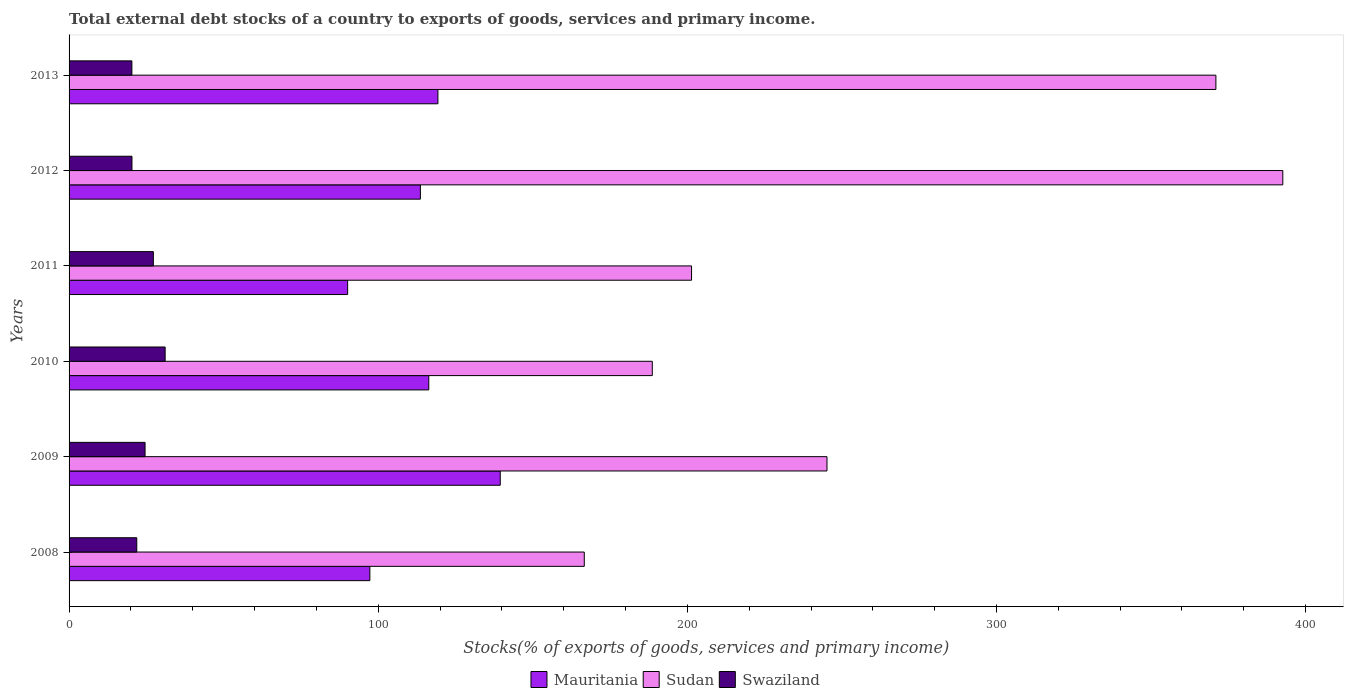How many groups of bars are there?
Keep it short and to the point. 6. Are the number of bars on each tick of the Y-axis equal?
Your response must be concise. Yes. How many bars are there on the 1st tick from the top?
Keep it short and to the point. 3. How many bars are there on the 6th tick from the bottom?
Offer a terse response. 3. What is the total debt stocks in Mauritania in 2010?
Your answer should be very brief. 116.36. Across all years, what is the maximum total debt stocks in Mauritania?
Give a very brief answer. 139.47. Across all years, what is the minimum total debt stocks in Sudan?
Make the answer very short. 166.66. In which year was the total debt stocks in Swaziland minimum?
Offer a terse response. 2013. What is the total total debt stocks in Swaziland in the graph?
Offer a terse response. 145.49. What is the difference between the total debt stocks in Mauritania in 2009 and that in 2011?
Ensure brevity in your answer.  49.37. What is the difference between the total debt stocks in Sudan in 2008 and the total debt stocks in Mauritania in 2012?
Make the answer very short. 53.01. What is the average total debt stocks in Swaziland per year?
Keep it short and to the point. 24.25. In the year 2011, what is the difference between the total debt stocks in Sudan and total debt stocks in Swaziland?
Your answer should be very brief. 174.09. What is the ratio of the total debt stocks in Mauritania in 2012 to that in 2013?
Provide a short and direct response. 0.95. Is the difference between the total debt stocks in Sudan in 2009 and 2011 greater than the difference between the total debt stocks in Swaziland in 2009 and 2011?
Your answer should be very brief. Yes. What is the difference between the highest and the second highest total debt stocks in Swaziland?
Your response must be concise. 3.81. What is the difference between the highest and the lowest total debt stocks in Mauritania?
Provide a short and direct response. 49.37. Is the sum of the total debt stocks in Swaziland in 2010 and 2012 greater than the maximum total debt stocks in Mauritania across all years?
Keep it short and to the point. No. What does the 2nd bar from the top in 2008 represents?
Make the answer very short. Sudan. What does the 3rd bar from the bottom in 2010 represents?
Your answer should be very brief. Swaziland. How many bars are there?
Provide a short and direct response. 18. How many years are there in the graph?
Your answer should be compact. 6. What is the difference between two consecutive major ticks on the X-axis?
Offer a terse response. 100. Does the graph contain any zero values?
Keep it short and to the point. No. How are the legend labels stacked?
Keep it short and to the point. Horizontal. What is the title of the graph?
Your answer should be very brief. Total external debt stocks of a country to exports of goods, services and primary income. Does "Middle East & North Africa (developing only)" appear as one of the legend labels in the graph?
Offer a terse response. No. What is the label or title of the X-axis?
Your answer should be very brief. Stocks(% of exports of goods, services and primary income). What is the label or title of the Y-axis?
Provide a succinct answer. Years. What is the Stocks(% of exports of goods, services and primary income) in Mauritania in 2008?
Offer a terse response. 97.3. What is the Stocks(% of exports of goods, services and primary income) in Sudan in 2008?
Give a very brief answer. 166.66. What is the Stocks(% of exports of goods, services and primary income) of Swaziland in 2008?
Offer a terse response. 21.91. What is the Stocks(% of exports of goods, services and primary income) in Mauritania in 2009?
Provide a succinct answer. 139.47. What is the Stocks(% of exports of goods, services and primary income) in Sudan in 2009?
Ensure brevity in your answer.  245.16. What is the Stocks(% of exports of goods, services and primary income) in Swaziland in 2009?
Your response must be concise. 24.58. What is the Stocks(% of exports of goods, services and primary income) in Mauritania in 2010?
Provide a short and direct response. 116.36. What is the Stocks(% of exports of goods, services and primary income) of Sudan in 2010?
Your answer should be compact. 188.66. What is the Stocks(% of exports of goods, services and primary income) of Swaziland in 2010?
Provide a short and direct response. 31.08. What is the Stocks(% of exports of goods, services and primary income) in Mauritania in 2011?
Your response must be concise. 90.11. What is the Stocks(% of exports of goods, services and primary income) in Sudan in 2011?
Ensure brevity in your answer.  201.36. What is the Stocks(% of exports of goods, services and primary income) in Swaziland in 2011?
Keep it short and to the point. 27.26. What is the Stocks(% of exports of goods, services and primary income) in Mauritania in 2012?
Give a very brief answer. 113.64. What is the Stocks(% of exports of goods, services and primary income) in Sudan in 2012?
Provide a succinct answer. 392.61. What is the Stocks(% of exports of goods, services and primary income) of Swaziland in 2012?
Keep it short and to the point. 20.34. What is the Stocks(% of exports of goods, services and primary income) of Mauritania in 2013?
Your answer should be compact. 119.31. What is the Stocks(% of exports of goods, services and primary income) of Sudan in 2013?
Offer a very short reply. 370.97. What is the Stocks(% of exports of goods, services and primary income) in Swaziland in 2013?
Offer a terse response. 20.32. Across all years, what is the maximum Stocks(% of exports of goods, services and primary income) in Mauritania?
Your answer should be compact. 139.47. Across all years, what is the maximum Stocks(% of exports of goods, services and primary income) of Sudan?
Offer a very short reply. 392.61. Across all years, what is the maximum Stocks(% of exports of goods, services and primary income) in Swaziland?
Your response must be concise. 31.08. Across all years, what is the minimum Stocks(% of exports of goods, services and primary income) of Mauritania?
Your response must be concise. 90.11. Across all years, what is the minimum Stocks(% of exports of goods, services and primary income) of Sudan?
Offer a very short reply. 166.66. Across all years, what is the minimum Stocks(% of exports of goods, services and primary income) in Swaziland?
Provide a succinct answer. 20.32. What is the total Stocks(% of exports of goods, services and primary income) in Mauritania in the graph?
Your answer should be compact. 676.2. What is the total Stocks(% of exports of goods, services and primary income) in Sudan in the graph?
Your answer should be compact. 1565.42. What is the total Stocks(% of exports of goods, services and primary income) of Swaziland in the graph?
Your answer should be compact. 145.49. What is the difference between the Stocks(% of exports of goods, services and primary income) in Mauritania in 2008 and that in 2009?
Ensure brevity in your answer.  -42.18. What is the difference between the Stocks(% of exports of goods, services and primary income) in Sudan in 2008 and that in 2009?
Keep it short and to the point. -78.51. What is the difference between the Stocks(% of exports of goods, services and primary income) of Swaziland in 2008 and that in 2009?
Provide a short and direct response. -2.68. What is the difference between the Stocks(% of exports of goods, services and primary income) of Mauritania in 2008 and that in 2010?
Offer a terse response. -19.06. What is the difference between the Stocks(% of exports of goods, services and primary income) in Sudan in 2008 and that in 2010?
Give a very brief answer. -22. What is the difference between the Stocks(% of exports of goods, services and primary income) of Swaziland in 2008 and that in 2010?
Ensure brevity in your answer.  -9.17. What is the difference between the Stocks(% of exports of goods, services and primary income) of Mauritania in 2008 and that in 2011?
Your response must be concise. 7.19. What is the difference between the Stocks(% of exports of goods, services and primary income) of Sudan in 2008 and that in 2011?
Keep it short and to the point. -34.7. What is the difference between the Stocks(% of exports of goods, services and primary income) in Swaziland in 2008 and that in 2011?
Provide a short and direct response. -5.36. What is the difference between the Stocks(% of exports of goods, services and primary income) in Mauritania in 2008 and that in 2012?
Your answer should be compact. -16.35. What is the difference between the Stocks(% of exports of goods, services and primary income) of Sudan in 2008 and that in 2012?
Give a very brief answer. -225.96. What is the difference between the Stocks(% of exports of goods, services and primary income) in Swaziland in 2008 and that in 2012?
Offer a very short reply. 1.56. What is the difference between the Stocks(% of exports of goods, services and primary income) of Mauritania in 2008 and that in 2013?
Provide a short and direct response. -22.01. What is the difference between the Stocks(% of exports of goods, services and primary income) in Sudan in 2008 and that in 2013?
Offer a terse response. -204.31. What is the difference between the Stocks(% of exports of goods, services and primary income) of Swaziland in 2008 and that in 2013?
Make the answer very short. 1.58. What is the difference between the Stocks(% of exports of goods, services and primary income) of Mauritania in 2009 and that in 2010?
Make the answer very short. 23.12. What is the difference between the Stocks(% of exports of goods, services and primary income) in Sudan in 2009 and that in 2010?
Keep it short and to the point. 56.51. What is the difference between the Stocks(% of exports of goods, services and primary income) in Swaziland in 2009 and that in 2010?
Offer a very short reply. -6.49. What is the difference between the Stocks(% of exports of goods, services and primary income) of Mauritania in 2009 and that in 2011?
Offer a terse response. 49.37. What is the difference between the Stocks(% of exports of goods, services and primary income) in Sudan in 2009 and that in 2011?
Ensure brevity in your answer.  43.81. What is the difference between the Stocks(% of exports of goods, services and primary income) in Swaziland in 2009 and that in 2011?
Your response must be concise. -2.68. What is the difference between the Stocks(% of exports of goods, services and primary income) in Mauritania in 2009 and that in 2012?
Provide a short and direct response. 25.83. What is the difference between the Stocks(% of exports of goods, services and primary income) of Sudan in 2009 and that in 2012?
Your answer should be compact. -147.45. What is the difference between the Stocks(% of exports of goods, services and primary income) of Swaziland in 2009 and that in 2012?
Make the answer very short. 4.24. What is the difference between the Stocks(% of exports of goods, services and primary income) in Mauritania in 2009 and that in 2013?
Ensure brevity in your answer.  20.16. What is the difference between the Stocks(% of exports of goods, services and primary income) in Sudan in 2009 and that in 2013?
Your response must be concise. -125.81. What is the difference between the Stocks(% of exports of goods, services and primary income) of Swaziland in 2009 and that in 2013?
Give a very brief answer. 4.26. What is the difference between the Stocks(% of exports of goods, services and primary income) in Mauritania in 2010 and that in 2011?
Give a very brief answer. 26.25. What is the difference between the Stocks(% of exports of goods, services and primary income) of Sudan in 2010 and that in 2011?
Ensure brevity in your answer.  -12.7. What is the difference between the Stocks(% of exports of goods, services and primary income) of Swaziland in 2010 and that in 2011?
Offer a very short reply. 3.81. What is the difference between the Stocks(% of exports of goods, services and primary income) of Mauritania in 2010 and that in 2012?
Your response must be concise. 2.71. What is the difference between the Stocks(% of exports of goods, services and primary income) in Sudan in 2010 and that in 2012?
Give a very brief answer. -203.96. What is the difference between the Stocks(% of exports of goods, services and primary income) in Swaziland in 2010 and that in 2012?
Your answer should be compact. 10.73. What is the difference between the Stocks(% of exports of goods, services and primary income) in Mauritania in 2010 and that in 2013?
Your response must be concise. -2.96. What is the difference between the Stocks(% of exports of goods, services and primary income) of Sudan in 2010 and that in 2013?
Give a very brief answer. -182.31. What is the difference between the Stocks(% of exports of goods, services and primary income) in Swaziland in 2010 and that in 2013?
Offer a terse response. 10.76. What is the difference between the Stocks(% of exports of goods, services and primary income) in Mauritania in 2011 and that in 2012?
Make the answer very short. -23.53. What is the difference between the Stocks(% of exports of goods, services and primary income) of Sudan in 2011 and that in 2012?
Provide a short and direct response. -191.26. What is the difference between the Stocks(% of exports of goods, services and primary income) in Swaziland in 2011 and that in 2012?
Give a very brief answer. 6.92. What is the difference between the Stocks(% of exports of goods, services and primary income) of Mauritania in 2011 and that in 2013?
Provide a succinct answer. -29.2. What is the difference between the Stocks(% of exports of goods, services and primary income) of Sudan in 2011 and that in 2013?
Ensure brevity in your answer.  -169.61. What is the difference between the Stocks(% of exports of goods, services and primary income) in Swaziland in 2011 and that in 2013?
Your answer should be compact. 6.94. What is the difference between the Stocks(% of exports of goods, services and primary income) in Mauritania in 2012 and that in 2013?
Keep it short and to the point. -5.67. What is the difference between the Stocks(% of exports of goods, services and primary income) in Sudan in 2012 and that in 2013?
Make the answer very short. 21.64. What is the difference between the Stocks(% of exports of goods, services and primary income) in Swaziland in 2012 and that in 2013?
Your response must be concise. 0.02. What is the difference between the Stocks(% of exports of goods, services and primary income) in Mauritania in 2008 and the Stocks(% of exports of goods, services and primary income) in Sudan in 2009?
Provide a short and direct response. -147.87. What is the difference between the Stocks(% of exports of goods, services and primary income) of Mauritania in 2008 and the Stocks(% of exports of goods, services and primary income) of Swaziland in 2009?
Make the answer very short. 72.72. What is the difference between the Stocks(% of exports of goods, services and primary income) of Sudan in 2008 and the Stocks(% of exports of goods, services and primary income) of Swaziland in 2009?
Your answer should be very brief. 142.07. What is the difference between the Stocks(% of exports of goods, services and primary income) in Mauritania in 2008 and the Stocks(% of exports of goods, services and primary income) in Sudan in 2010?
Give a very brief answer. -91.36. What is the difference between the Stocks(% of exports of goods, services and primary income) of Mauritania in 2008 and the Stocks(% of exports of goods, services and primary income) of Swaziland in 2010?
Provide a succinct answer. 66.22. What is the difference between the Stocks(% of exports of goods, services and primary income) of Sudan in 2008 and the Stocks(% of exports of goods, services and primary income) of Swaziland in 2010?
Your answer should be compact. 135.58. What is the difference between the Stocks(% of exports of goods, services and primary income) in Mauritania in 2008 and the Stocks(% of exports of goods, services and primary income) in Sudan in 2011?
Your response must be concise. -104.06. What is the difference between the Stocks(% of exports of goods, services and primary income) in Mauritania in 2008 and the Stocks(% of exports of goods, services and primary income) in Swaziland in 2011?
Offer a very short reply. 70.03. What is the difference between the Stocks(% of exports of goods, services and primary income) of Sudan in 2008 and the Stocks(% of exports of goods, services and primary income) of Swaziland in 2011?
Provide a short and direct response. 139.39. What is the difference between the Stocks(% of exports of goods, services and primary income) in Mauritania in 2008 and the Stocks(% of exports of goods, services and primary income) in Sudan in 2012?
Provide a succinct answer. -295.31. What is the difference between the Stocks(% of exports of goods, services and primary income) in Mauritania in 2008 and the Stocks(% of exports of goods, services and primary income) in Swaziland in 2012?
Offer a terse response. 76.96. What is the difference between the Stocks(% of exports of goods, services and primary income) in Sudan in 2008 and the Stocks(% of exports of goods, services and primary income) in Swaziland in 2012?
Ensure brevity in your answer.  146.31. What is the difference between the Stocks(% of exports of goods, services and primary income) in Mauritania in 2008 and the Stocks(% of exports of goods, services and primary income) in Sudan in 2013?
Provide a succinct answer. -273.67. What is the difference between the Stocks(% of exports of goods, services and primary income) in Mauritania in 2008 and the Stocks(% of exports of goods, services and primary income) in Swaziland in 2013?
Give a very brief answer. 76.98. What is the difference between the Stocks(% of exports of goods, services and primary income) in Sudan in 2008 and the Stocks(% of exports of goods, services and primary income) in Swaziland in 2013?
Your response must be concise. 146.34. What is the difference between the Stocks(% of exports of goods, services and primary income) in Mauritania in 2009 and the Stocks(% of exports of goods, services and primary income) in Sudan in 2010?
Keep it short and to the point. -49.18. What is the difference between the Stocks(% of exports of goods, services and primary income) of Mauritania in 2009 and the Stocks(% of exports of goods, services and primary income) of Swaziland in 2010?
Offer a very short reply. 108.4. What is the difference between the Stocks(% of exports of goods, services and primary income) in Sudan in 2009 and the Stocks(% of exports of goods, services and primary income) in Swaziland in 2010?
Provide a short and direct response. 214.09. What is the difference between the Stocks(% of exports of goods, services and primary income) in Mauritania in 2009 and the Stocks(% of exports of goods, services and primary income) in Sudan in 2011?
Give a very brief answer. -61.88. What is the difference between the Stocks(% of exports of goods, services and primary income) in Mauritania in 2009 and the Stocks(% of exports of goods, services and primary income) in Swaziland in 2011?
Make the answer very short. 112.21. What is the difference between the Stocks(% of exports of goods, services and primary income) of Sudan in 2009 and the Stocks(% of exports of goods, services and primary income) of Swaziland in 2011?
Give a very brief answer. 217.9. What is the difference between the Stocks(% of exports of goods, services and primary income) of Mauritania in 2009 and the Stocks(% of exports of goods, services and primary income) of Sudan in 2012?
Your answer should be very brief. -253.14. What is the difference between the Stocks(% of exports of goods, services and primary income) of Mauritania in 2009 and the Stocks(% of exports of goods, services and primary income) of Swaziland in 2012?
Offer a very short reply. 119.13. What is the difference between the Stocks(% of exports of goods, services and primary income) in Sudan in 2009 and the Stocks(% of exports of goods, services and primary income) in Swaziland in 2012?
Ensure brevity in your answer.  224.82. What is the difference between the Stocks(% of exports of goods, services and primary income) of Mauritania in 2009 and the Stocks(% of exports of goods, services and primary income) of Sudan in 2013?
Make the answer very short. -231.5. What is the difference between the Stocks(% of exports of goods, services and primary income) of Mauritania in 2009 and the Stocks(% of exports of goods, services and primary income) of Swaziland in 2013?
Give a very brief answer. 119.15. What is the difference between the Stocks(% of exports of goods, services and primary income) of Sudan in 2009 and the Stocks(% of exports of goods, services and primary income) of Swaziland in 2013?
Give a very brief answer. 224.84. What is the difference between the Stocks(% of exports of goods, services and primary income) in Mauritania in 2010 and the Stocks(% of exports of goods, services and primary income) in Sudan in 2011?
Make the answer very short. -85. What is the difference between the Stocks(% of exports of goods, services and primary income) in Mauritania in 2010 and the Stocks(% of exports of goods, services and primary income) in Swaziland in 2011?
Provide a succinct answer. 89.09. What is the difference between the Stocks(% of exports of goods, services and primary income) in Sudan in 2010 and the Stocks(% of exports of goods, services and primary income) in Swaziland in 2011?
Offer a terse response. 161.39. What is the difference between the Stocks(% of exports of goods, services and primary income) in Mauritania in 2010 and the Stocks(% of exports of goods, services and primary income) in Sudan in 2012?
Ensure brevity in your answer.  -276.26. What is the difference between the Stocks(% of exports of goods, services and primary income) of Mauritania in 2010 and the Stocks(% of exports of goods, services and primary income) of Swaziland in 2012?
Keep it short and to the point. 96.01. What is the difference between the Stocks(% of exports of goods, services and primary income) of Sudan in 2010 and the Stocks(% of exports of goods, services and primary income) of Swaziland in 2012?
Provide a succinct answer. 168.31. What is the difference between the Stocks(% of exports of goods, services and primary income) of Mauritania in 2010 and the Stocks(% of exports of goods, services and primary income) of Sudan in 2013?
Your answer should be very brief. -254.61. What is the difference between the Stocks(% of exports of goods, services and primary income) in Mauritania in 2010 and the Stocks(% of exports of goods, services and primary income) in Swaziland in 2013?
Keep it short and to the point. 96.04. What is the difference between the Stocks(% of exports of goods, services and primary income) of Sudan in 2010 and the Stocks(% of exports of goods, services and primary income) of Swaziland in 2013?
Provide a short and direct response. 168.34. What is the difference between the Stocks(% of exports of goods, services and primary income) of Mauritania in 2011 and the Stocks(% of exports of goods, services and primary income) of Sudan in 2012?
Your response must be concise. -302.5. What is the difference between the Stocks(% of exports of goods, services and primary income) in Mauritania in 2011 and the Stocks(% of exports of goods, services and primary income) in Swaziland in 2012?
Give a very brief answer. 69.77. What is the difference between the Stocks(% of exports of goods, services and primary income) in Sudan in 2011 and the Stocks(% of exports of goods, services and primary income) in Swaziland in 2012?
Make the answer very short. 181.01. What is the difference between the Stocks(% of exports of goods, services and primary income) in Mauritania in 2011 and the Stocks(% of exports of goods, services and primary income) in Sudan in 2013?
Offer a very short reply. -280.86. What is the difference between the Stocks(% of exports of goods, services and primary income) of Mauritania in 2011 and the Stocks(% of exports of goods, services and primary income) of Swaziland in 2013?
Give a very brief answer. 69.79. What is the difference between the Stocks(% of exports of goods, services and primary income) in Sudan in 2011 and the Stocks(% of exports of goods, services and primary income) in Swaziland in 2013?
Your answer should be very brief. 181.03. What is the difference between the Stocks(% of exports of goods, services and primary income) of Mauritania in 2012 and the Stocks(% of exports of goods, services and primary income) of Sudan in 2013?
Keep it short and to the point. -257.33. What is the difference between the Stocks(% of exports of goods, services and primary income) of Mauritania in 2012 and the Stocks(% of exports of goods, services and primary income) of Swaziland in 2013?
Make the answer very short. 93.32. What is the difference between the Stocks(% of exports of goods, services and primary income) of Sudan in 2012 and the Stocks(% of exports of goods, services and primary income) of Swaziland in 2013?
Ensure brevity in your answer.  372.29. What is the average Stocks(% of exports of goods, services and primary income) of Mauritania per year?
Your response must be concise. 112.7. What is the average Stocks(% of exports of goods, services and primary income) of Sudan per year?
Your answer should be very brief. 260.9. What is the average Stocks(% of exports of goods, services and primary income) of Swaziland per year?
Offer a terse response. 24.25. In the year 2008, what is the difference between the Stocks(% of exports of goods, services and primary income) of Mauritania and Stocks(% of exports of goods, services and primary income) of Sudan?
Your answer should be compact. -69.36. In the year 2008, what is the difference between the Stocks(% of exports of goods, services and primary income) in Mauritania and Stocks(% of exports of goods, services and primary income) in Swaziland?
Ensure brevity in your answer.  75.39. In the year 2008, what is the difference between the Stocks(% of exports of goods, services and primary income) in Sudan and Stocks(% of exports of goods, services and primary income) in Swaziland?
Give a very brief answer. 144.75. In the year 2009, what is the difference between the Stocks(% of exports of goods, services and primary income) of Mauritania and Stocks(% of exports of goods, services and primary income) of Sudan?
Make the answer very short. -105.69. In the year 2009, what is the difference between the Stocks(% of exports of goods, services and primary income) in Mauritania and Stocks(% of exports of goods, services and primary income) in Swaziland?
Give a very brief answer. 114.89. In the year 2009, what is the difference between the Stocks(% of exports of goods, services and primary income) in Sudan and Stocks(% of exports of goods, services and primary income) in Swaziland?
Offer a terse response. 220.58. In the year 2010, what is the difference between the Stocks(% of exports of goods, services and primary income) in Mauritania and Stocks(% of exports of goods, services and primary income) in Sudan?
Provide a succinct answer. -72.3. In the year 2010, what is the difference between the Stocks(% of exports of goods, services and primary income) in Mauritania and Stocks(% of exports of goods, services and primary income) in Swaziland?
Offer a very short reply. 85.28. In the year 2010, what is the difference between the Stocks(% of exports of goods, services and primary income) of Sudan and Stocks(% of exports of goods, services and primary income) of Swaziland?
Your answer should be very brief. 157.58. In the year 2011, what is the difference between the Stocks(% of exports of goods, services and primary income) in Mauritania and Stocks(% of exports of goods, services and primary income) in Sudan?
Your response must be concise. -111.25. In the year 2011, what is the difference between the Stocks(% of exports of goods, services and primary income) in Mauritania and Stocks(% of exports of goods, services and primary income) in Swaziland?
Your answer should be very brief. 62.85. In the year 2011, what is the difference between the Stocks(% of exports of goods, services and primary income) of Sudan and Stocks(% of exports of goods, services and primary income) of Swaziland?
Make the answer very short. 174.09. In the year 2012, what is the difference between the Stocks(% of exports of goods, services and primary income) in Mauritania and Stocks(% of exports of goods, services and primary income) in Sudan?
Make the answer very short. -278.97. In the year 2012, what is the difference between the Stocks(% of exports of goods, services and primary income) of Mauritania and Stocks(% of exports of goods, services and primary income) of Swaziland?
Provide a succinct answer. 93.3. In the year 2012, what is the difference between the Stocks(% of exports of goods, services and primary income) in Sudan and Stocks(% of exports of goods, services and primary income) in Swaziland?
Your answer should be very brief. 372.27. In the year 2013, what is the difference between the Stocks(% of exports of goods, services and primary income) of Mauritania and Stocks(% of exports of goods, services and primary income) of Sudan?
Offer a very short reply. -251.66. In the year 2013, what is the difference between the Stocks(% of exports of goods, services and primary income) in Mauritania and Stocks(% of exports of goods, services and primary income) in Swaziland?
Ensure brevity in your answer.  98.99. In the year 2013, what is the difference between the Stocks(% of exports of goods, services and primary income) of Sudan and Stocks(% of exports of goods, services and primary income) of Swaziland?
Your answer should be compact. 350.65. What is the ratio of the Stocks(% of exports of goods, services and primary income) of Mauritania in 2008 to that in 2009?
Your answer should be compact. 0.7. What is the ratio of the Stocks(% of exports of goods, services and primary income) in Sudan in 2008 to that in 2009?
Provide a short and direct response. 0.68. What is the ratio of the Stocks(% of exports of goods, services and primary income) in Swaziland in 2008 to that in 2009?
Offer a terse response. 0.89. What is the ratio of the Stocks(% of exports of goods, services and primary income) in Mauritania in 2008 to that in 2010?
Provide a short and direct response. 0.84. What is the ratio of the Stocks(% of exports of goods, services and primary income) in Sudan in 2008 to that in 2010?
Offer a terse response. 0.88. What is the ratio of the Stocks(% of exports of goods, services and primary income) of Swaziland in 2008 to that in 2010?
Your answer should be compact. 0.7. What is the ratio of the Stocks(% of exports of goods, services and primary income) in Mauritania in 2008 to that in 2011?
Make the answer very short. 1.08. What is the ratio of the Stocks(% of exports of goods, services and primary income) in Sudan in 2008 to that in 2011?
Make the answer very short. 0.83. What is the ratio of the Stocks(% of exports of goods, services and primary income) in Swaziland in 2008 to that in 2011?
Keep it short and to the point. 0.8. What is the ratio of the Stocks(% of exports of goods, services and primary income) in Mauritania in 2008 to that in 2012?
Offer a very short reply. 0.86. What is the ratio of the Stocks(% of exports of goods, services and primary income) of Sudan in 2008 to that in 2012?
Make the answer very short. 0.42. What is the ratio of the Stocks(% of exports of goods, services and primary income) in Swaziland in 2008 to that in 2012?
Provide a succinct answer. 1.08. What is the ratio of the Stocks(% of exports of goods, services and primary income) in Mauritania in 2008 to that in 2013?
Ensure brevity in your answer.  0.82. What is the ratio of the Stocks(% of exports of goods, services and primary income) in Sudan in 2008 to that in 2013?
Your answer should be compact. 0.45. What is the ratio of the Stocks(% of exports of goods, services and primary income) of Swaziland in 2008 to that in 2013?
Give a very brief answer. 1.08. What is the ratio of the Stocks(% of exports of goods, services and primary income) in Mauritania in 2009 to that in 2010?
Ensure brevity in your answer.  1.2. What is the ratio of the Stocks(% of exports of goods, services and primary income) of Sudan in 2009 to that in 2010?
Keep it short and to the point. 1.3. What is the ratio of the Stocks(% of exports of goods, services and primary income) in Swaziland in 2009 to that in 2010?
Make the answer very short. 0.79. What is the ratio of the Stocks(% of exports of goods, services and primary income) of Mauritania in 2009 to that in 2011?
Provide a succinct answer. 1.55. What is the ratio of the Stocks(% of exports of goods, services and primary income) of Sudan in 2009 to that in 2011?
Give a very brief answer. 1.22. What is the ratio of the Stocks(% of exports of goods, services and primary income) in Swaziland in 2009 to that in 2011?
Your answer should be compact. 0.9. What is the ratio of the Stocks(% of exports of goods, services and primary income) of Mauritania in 2009 to that in 2012?
Ensure brevity in your answer.  1.23. What is the ratio of the Stocks(% of exports of goods, services and primary income) of Sudan in 2009 to that in 2012?
Provide a succinct answer. 0.62. What is the ratio of the Stocks(% of exports of goods, services and primary income) of Swaziland in 2009 to that in 2012?
Provide a succinct answer. 1.21. What is the ratio of the Stocks(% of exports of goods, services and primary income) in Mauritania in 2009 to that in 2013?
Your response must be concise. 1.17. What is the ratio of the Stocks(% of exports of goods, services and primary income) in Sudan in 2009 to that in 2013?
Ensure brevity in your answer.  0.66. What is the ratio of the Stocks(% of exports of goods, services and primary income) in Swaziland in 2009 to that in 2013?
Provide a succinct answer. 1.21. What is the ratio of the Stocks(% of exports of goods, services and primary income) of Mauritania in 2010 to that in 2011?
Your answer should be compact. 1.29. What is the ratio of the Stocks(% of exports of goods, services and primary income) in Sudan in 2010 to that in 2011?
Your response must be concise. 0.94. What is the ratio of the Stocks(% of exports of goods, services and primary income) in Swaziland in 2010 to that in 2011?
Your answer should be very brief. 1.14. What is the ratio of the Stocks(% of exports of goods, services and primary income) of Mauritania in 2010 to that in 2012?
Give a very brief answer. 1.02. What is the ratio of the Stocks(% of exports of goods, services and primary income) of Sudan in 2010 to that in 2012?
Make the answer very short. 0.48. What is the ratio of the Stocks(% of exports of goods, services and primary income) in Swaziland in 2010 to that in 2012?
Make the answer very short. 1.53. What is the ratio of the Stocks(% of exports of goods, services and primary income) in Mauritania in 2010 to that in 2013?
Your answer should be very brief. 0.98. What is the ratio of the Stocks(% of exports of goods, services and primary income) of Sudan in 2010 to that in 2013?
Make the answer very short. 0.51. What is the ratio of the Stocks(% of exports of goods, services and primary income) in Swaziland in 2010 to that in 2013?
Offer a terse response. 1.53. What is the ratio of the Stocks(% of exports of goods, services and primary income) of Mauritania in 2011 to that in 2012?
Your answer should be compact. 0.79. What is the ratio of the Stocks(% of exports of goods, services and primary income) of Sudan in 2011 to that in 2012?
Offer a very short reply. 0.51. What is the ratio of the Stocks(% of exports of goods, services and primary income) of Swaziland in 2011 to that in 2012?
Provide a short and direct response. 1.34. What is the ratio of the Stocks(% of exports of goods, services and primary income) in Mauritania in 2011 to that in 2013?
Provide a short and direct response. 0.76. What is the ratio of the Stocks(% of exports of goods, services and primary income) in Sudan in 2011 to that in 2013?
Keep it short and to the point. 0.54. What is the ratio of the Stocks(% of exports of goods, services and primary income) of Swaziland in 2011 to that in 2013?
Your response must be concise. 1.34. What is the ratio of the Stocks(% of exports of goods, services and primary income) in Mauritania in 2012 to that in 2013?
Give a very brief answer. 0.95. What is the ratio of the Stocks(% of exports of goods, services and primary income) of Sudan in 2012 to that in 2013?
Provide a short and direct response. 1.06. What is the difference between the highest and the second highest Stocks(% of exports of goods, services and primary income) in Mauritania?
Offer a terse response. 20.16. What is the difference between the highest and the second highest Stocks(% of exports of goods, services and primary income) in Sudan?
Offer a terse response. 21.64. What is the difference between the highest and the second highest Stocks(% of exports of goods, services and primary income) of Swaziland?
Provide a succinct answer. 3.81. What is the difference between the highest and the lowest Stocks(% of exports of goods, services and primary income) in Mauritania?
Offer a terse response. 49.37. What is the difference between the highest and the lowest Stocks(% of exports of goods, services and primary income) of Sudan?
Make the answer very short. 225.96. What is the difference between the highest and the lowest Stocks(% of exports of goods, services and primary income) in Swaziland?
Provide a short and direct response. 10.76. 